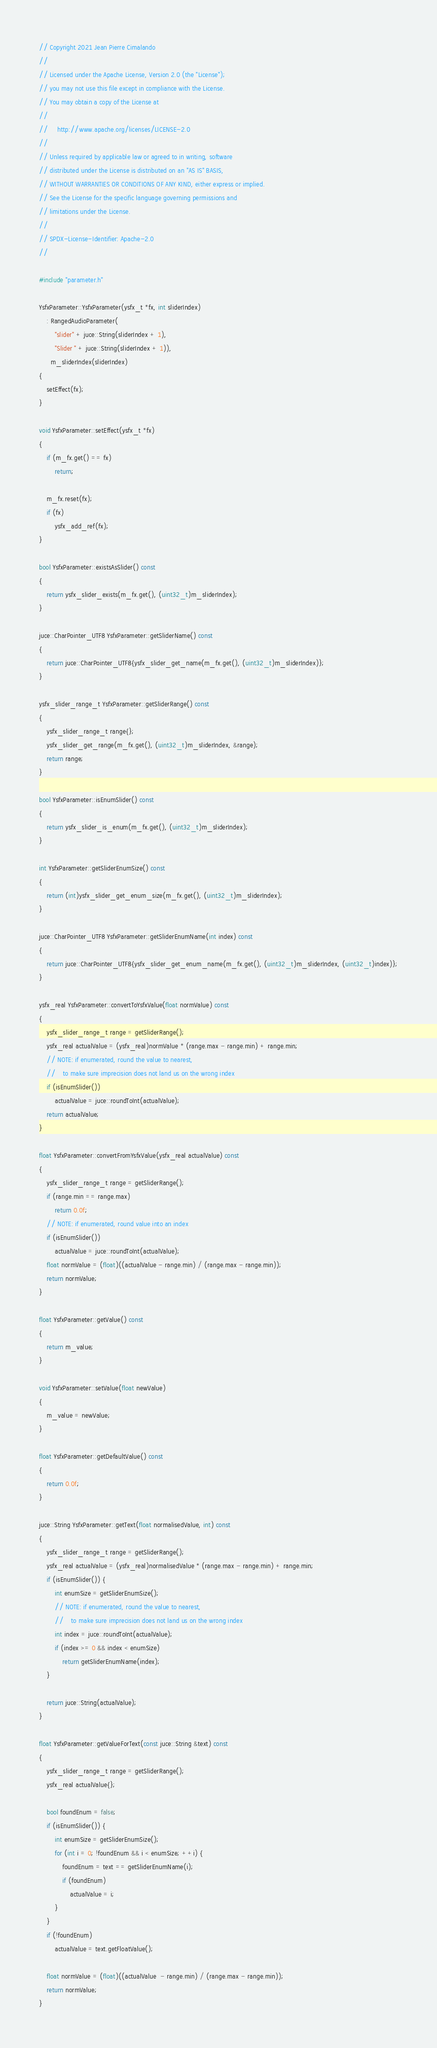Convert code to text. <code><loc_0><loc_0><loc_500><loc_500><_C++_>// Copyright 2021 Jean Pierre Cimalando
//
// Licensed under the Apache License, Version 2.0 (the "License");
// you may not use this file except in compliance with the License.
// You may obtain a copy of the License at
//
//     http://www.apache.org/licenses/LICENSE-2.0
//
// Unless required by applicable law or agreed to in writing, software
// distributed under the License is distributed on an "AS IS" BASIS,
// WITHOUT WARRANTIES OR CONDITIONS OF ANY KIND, either express or implied.
// See the License for the specific language governing permissions and
// limitations under the License.
//
// SPDX-License-Identifier: Apache-2.0
//

#include "parameter.h"

YsfxParameter::YsfxParameter(ysfx_t *fx, int sliderIndex)
    : RangedAudioParameter(
        "slider" + juce::String(sliderIndex + 1),
        "Slider " + juce::String(sliderIndex + 1)),
      m_sliderIndex(sliderIndex)
{
    setEffect(fx);
}

void YsfxParameter::setEffect(ysfx_t *fx)
{
    if (m_fx.get() == fx)
        return;

    m_fx.reset(fx);
    if (fx)
        ysfx_add_ref(fx);
}

bool YsfxParameter::existsAsSlider() const
{
    return ysfx_slider_exists(m_fx.get(), (uint32_t)m_sliderIndex);
}

juce::CharPointer_UTF8 YsfxParameter::getSliderName() const
{
    return juce::CharPointer_UTF8{ysfx_slider_get_name(m_fx.get(), (uint32_t)m_sliderIndex)};
}

ysfx_slider_range_t YsfxParameter::getSliderRange() const
{
    ysfx_slider_range_t range{};
    ysfx_slider_get_range(m_fx.get(), (uint32_t)m_sliderIndex, &range);
    return range;
}

bool YsfxParameter::isEnumSlider() const
{
    return ysfx_slider_is_enum(m_fx.get(), (uint32_t)m_sliderIndex);
}

int YsfxParameter::getSliderEnumSize() const
{
    return (int)ysfx_slider_get_enum_size(m_fx.get(), (uint32_t)m_sliderIndex);
}

juce::CharPointer_UTF8 YsfxParameter::getSliderEnumName(int index) const
{
    return juce::CharPointer_UTF8{ysfx_slider_get_enum_name(m_fx.get(), (uint32_t)m_sliderIndex, (uint32_t)index)};
}

ysfx_real YsfxParameter::convertToYsfxValue(float normValue) const
{
    ysfx_slider_range_t range = getSliderRange();
    ysfx_real actualValue = (ysfx_real)normValue * (range.max - range.min) + range.min;
    // NOTE: if enumerated, round the value to nearest,
    //    to make sure imprecision does not land us on the wrong index
    if (isEnumSlider())
        actualValue = juce::roundToInt(actualValue);
    return actualValue;
}

float YsfxParameter::convertFromYsfxValue(ysfx_real actualValue) const
{
    ysfx_slider_range_t range = getSliderRange();
    if (range.min == range.max)
        return 0.0f;
    // NOTE: if enumerated, round value into an index
    if (isEnumSlider())
        actualValue = juce::roundToInt(actualValue);
    float normValue = (float)((actualValue - range.min) / (range.max - range.min));
    return normValue;
}

float YsfxParameter::getValue() const
{
    return m_value;
}

void YsfxParameter::setValue(float newValue)
{
    m_value = newValue;
}

float YsfxParameter::getDefaultValue() const
{
    return 0.0f;
}

juce::String YsfxParameter::getText(float normalisedValue, int) const
{
    ysfx_slider_range_t range = getSliderRange();
    ysfx_real actualValue = (ysfx_real)normalisedValue * (range.max - range.min) + range.min;
    if (isEnumSlider()) {
        int enumSize = getSliderEnumSize();
        // NOTE: if enumerated, round the value to nearest,
        //    to make sure imprecision does not land us on the wrong index
        int index = juce::roundToInt(actualValue);
        if (index >= 0 && index < enumSize)
            return getSliderEnumName(index);
    }

    return juce::String(actualValue);
}

float YsfxParameter::getValueForText(const juce::String &text) const
{
    ysfx_slider_range_t range = getSliderRange();
    ysfx_real actualValue{};

    bool foundEnum = false;
    if (isEnumSlider()) {
        int enumSize = getSliderEnumSize();
        for (int i = 0; !foundEnum && i < enumSize; ++i) {
            foundEnum = text == getSliderEnumName(i);
            if (foundEnum)
                actualValue = i;
        }
    }
    if (!foundEnum)
        actualValue = text.getFloatValue();

    float normValue = (float)((actualValue  - range.min) / (range.max - range.min));
    return normValue;
}
</code> 